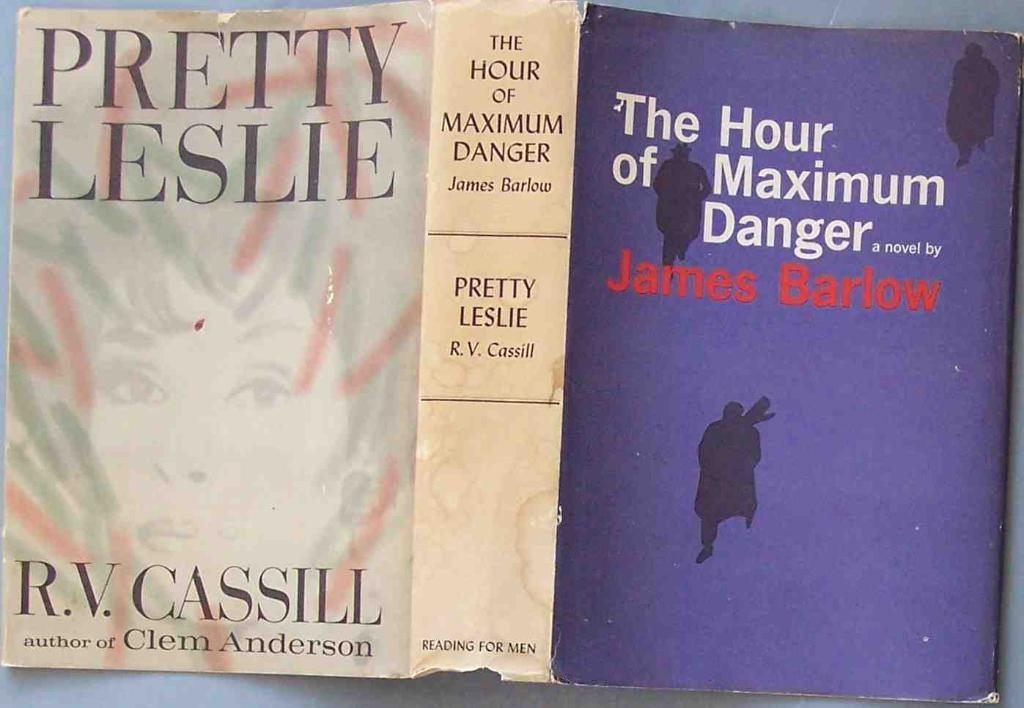<image>
Relay a brief, clear account of the picture shown. The dust jacket for the book Pretty Leslie by R.V. Cassill 